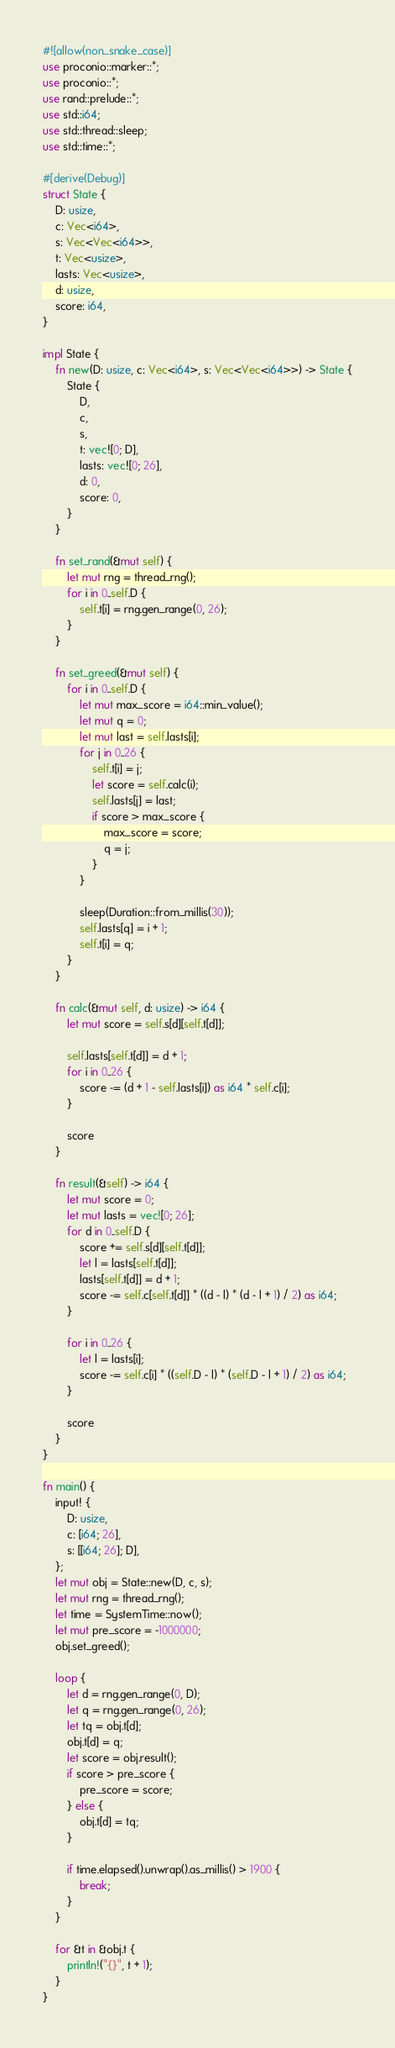<code> <loc_0><loc_0><loc_500><loc_500><_Rust_>#![allow(non_snake_case)]
use proconio::marker::*;
use proconio::*;
use rand::prelude::*;
use std::i64;
use std::thread::sleep;
use std::time::*;

#[derive(Debug)]
struct State {
    D: usize,
    c: Vec<i64>,
    s: Vec<Vec<i64>>,
    t: Vec<usize>,
    lasts: Vec<usize>,
    d: usize,
    score: i64,
}

impl State {
    fn new(D: usize, c: Vec<i64>, s: Vec<Vec<i64>>) -> State {
        State {
            D,
            c,
            s,
            t: vec![0; D],
            lasts: vec![0; 26],
            d: 0,
            score: 0,
        }
    }

    fn set_rand(&mut self) {
        let mut rng = thread_rng();
        for i in 0..self.D {
            self.t[i] = rng.gen_range(0, 26);
        }
    }

    fn set_greed(&mut self) {
        for i in 0..self.D {
            let mut max_score = i64::min_value();
            let mut q = 0;
            let mut last = self.lasts[i];
            for j in 0..26 {
                self.t[i] = j;
                let score = self.calc(i);
                self.lasts[j] = last;
                if score > max_score {
                    max_score = score;
                    q = j;
                }
            }

            sleep(Duration::from_millis(30));
            self.lasts[q] = i + 1;
            self.t[i] = q;
        }
    }

    fn calc(&mut self, d: usize) -> i64 {
        let mut score = self.s[d][self.t[d]];

        self.lasts[self.t[d]] = d + 1;
        for i in 0..26 {
            score -= (d + 1 - self.lasts[i]) as i64 * self.c[i];
        }

        score
    }

    fn result(&self) -> i64 {
        let mut score = 0;
        let mut lasts = vec![0; 26];
        for d in 0..self.D {
            score += self.s[d][self.t[d]];
            let l = lasts[self.t[d]];
            lasts[self.t[d]] = d + 1;
            score -= self.c[self.t[d]] * ((d - l) * (d - l + 1) / 2) as i64;
        }

        for i in 0..26 {
            let l = lasts[i];
            score -= self.c[i] * ((self.D - l) * (self.D - l + 1) / 2) as i64;
        }

        score
    }
}

fn main() {
    input! {
        D: usize,
        c: [i64; 26],
        s: [[i64; 26]; D],
    };
    let mut obj = State::new(D, c, s);
    let mut rng = thread_rng();
    let time = SystemTime::now();
    let mut pre_score = -1000000;
    obj.set_greed();

    loop {
        let d = rng.gen_range(0, D);
        let q = rng.gen_range(0, 26);
        let tq = obj.t[d];
        obj.t[d] = q;
        let score = obj.result();
        if score > pre_score {
            pre_score = score;
        } else {
            obj.t[d] = tq;
        }

        if time.elapsed().unwrap().as_millis() > 1900 {
            break;
        }
    }

    for &t in &obj.t {
        println!("{}", t + 1);
    }
}
</code> 